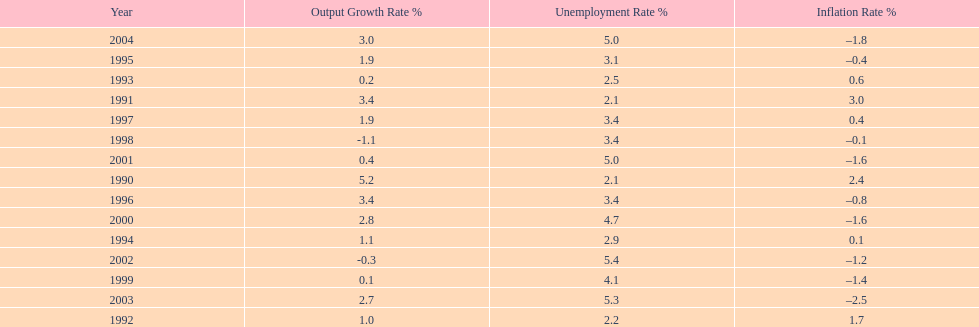In what years, between 1990 and 2004, did japan's unemployment rate reach 5% or higher? 4. 